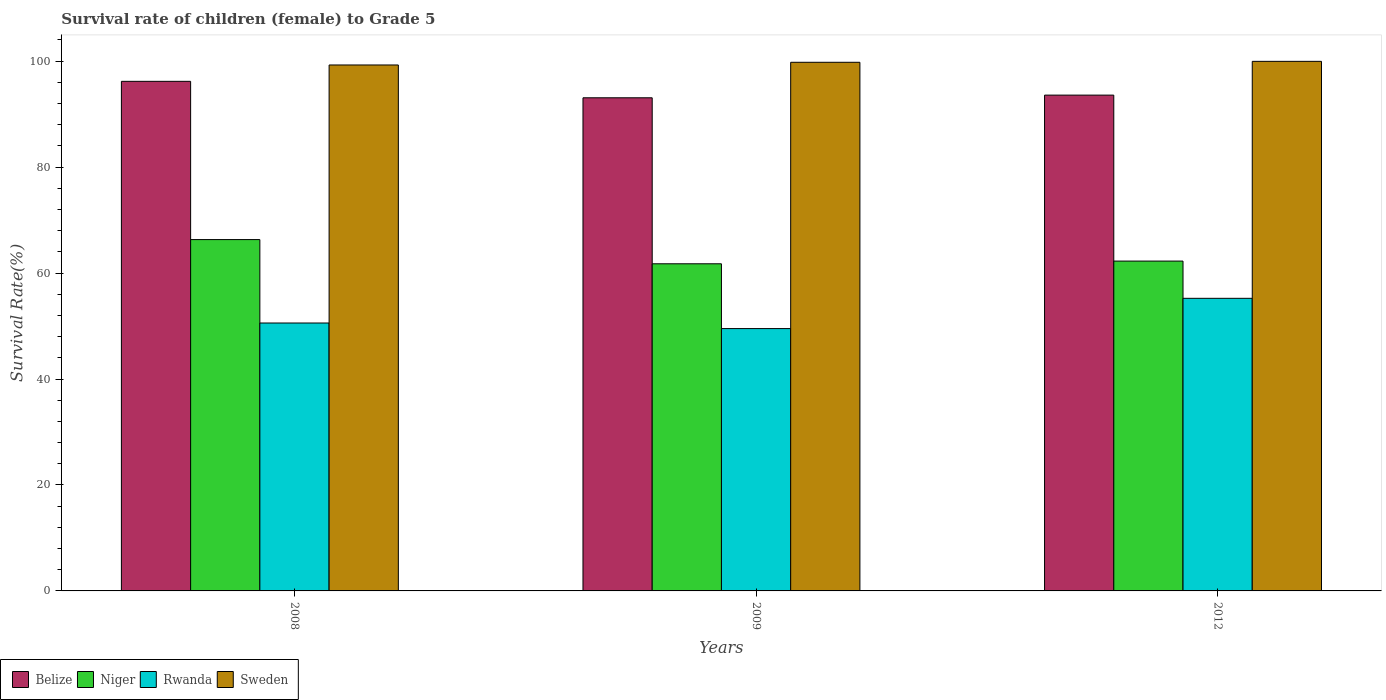How many different coloured bars are there?
Keep it short and to the point. 4. What is the label of the 1st group of bars from the left?
Offer a very short reply. 2008. In how many cases, is the number of bars for a given year not equal to the number of legend labels?
Your answer should be very brief. 0. What is the survival rate of female children to grade 5 in Niger in 2012?
Give a very brief answer. 62.26. Across all years, what is the maximum survival rate of female children to grade 5 in Sweden?
Provide a short and direct response. 99.96. Across all years, what is the minimum survival rate of female children to grade 5 in Sweden?
Make the answer very short. 99.28. In which year was the survival rate of female children to grade 5 in Niger maximum?
Keep it short and to the point. 2008. What is the total survival rate of female children to grade 5 in Rwanda in the graph?
Your answer should be compact. 155.33. What is the difference between the survival rate of female children to grade 5 in Sweden in 2009 and that in 2012?
Provide a short and direct response. -0.18. What is the difference between the survival rate of female children to grade 5 in Niger in 2008 and the survival rate of female children to grade 5 in Sweden in 2009?
Ensure brevity in your answer.  -33.47. What is the average survival rate of female children to grade 5 in Rwanda per year?
Give a very brief answer. 51.78. In the year 2012, what is the difference between the survival rate of female children to grade 5 in Niger and survival rate of female children to grade 5 in Rwanda?
Your response must be concise. 7.03. What is the ratio of the survival rate of female children to grade 5 in Rwanda in 2009 to that in 2012?
Your answer should be very brief. 0.9. What is the difference between the highest and the second highest survival rate of female children to grade 5 in Rwanda?
Provide a short and direct response. 4.66. What is the difference between the highest and the lowest survival rate of female children to grade 5 in Niger?
Keep it short and to the point. 4.57. In how many years, is the survival rate of female children to grade 5 in Belize greater than the average survival rate of female children to grade 5 in Belize taken over all years?
Offer a terse response. 1. What does the 3rd bar from the right in 2009 represents?
Provide a short and direct response. Niger. How many bars are there?
Give a very brief answer. 12. Are all the bars in the graph horizontal?
Make the answer very short. No. What is the difference between two consecutive major ticks on the Y-axis?
Your answer should be very brief. 20. Are the values on the major ticks of Y-axis written in scientific E-notation?
Provide a short and direct response. No. Does the graph contain grids?
Keep it short and to the point. No. Where does the legend appear in the graph?
Offer a terse response. Bottom left. How are the legend labels stacked?
Give a very brief answer. Horizontal. What is the title of the graph?
Give a very brief answer. Survival rate of children (female) to Grade 5. Does "Grenada" appear as one of the legend labels in the graph?
Keep it short and to the point. No. What is the label or title of the Y-axis?
Give a very brief answer. Survival Rate(%). What is the Survival Rate(%) of Belize in 2008?
Provide a short and direct response. 96.19. What is the Survival Rate(%) of Niger in 2008?
Give a very brief answer. 66.32. What is the Survival Rate(%) in Rwanda in 2008?
Your answer should be compact. 50.57. What is the Survival Rate(%) in Sweden in 2008?
Provide a short and direct response. 99.28. What is the Survival Rate(%) of Belize in 2009?
Offer a very short reply. 93.09. What is the Survival Rate(%) in Niger in 2009?
Make the answer very short. 61.75. What is the Survival Rate(%) in Rwanda in 2009?
Offer a very short reply. 49.52. What is the Survival Rate(%) of Sweden in 2009?
Your answer should be very brief. 99.79. What is the Survival Rate(%) of Belize in 2012?
Provide a short and direct response. 93.59. What is the Survival Rate(%) of Niger in 2012?
Your response must be concise. 62.26. What is the Survival Rate(%) in Rwanda in 2012?
Your answer should be compact. 55.23. What is the Survival Rate(%) in Sweden in 2012?
Offer a terse response. 99.96. Across all years, what is the maximum Survival Rate(%) of Belize?
Keep it short and to the point. 96.19. Across all years, what is the maximum Survival Rate(%) of Niger?
Make the answer very short. 66.32. Across all years, what is the maximum Survival Rate(%) of Rwanda?
Ensure brevity in your answer.  55.23. Across all years, what is the maximum Survival Rate(%) of Sweden?
Give a very brief answer. 99.96. Across all years, what is the minimum Survival Rate(%) of Belize?
Make the answer very short. 93.09. Across all years, what is the minimum Survival Rate(%) of Niger?
Offer a very short reply. 61.75. Across all years, what is the minimum Survival Rate(%) of Rwanda?
Keep it short and to the point. 49.52. Across all years, what is the minimum Survival Rate(%) in Sweden?
Keep it short and to the point. 99.28. What is the total Survival Rate(%) of Belize in the graph?
Provide a succinct answer. 282.87. What is the total Survival Rate(%) in Niger in the graph?
Provide a succinct answer. 190.33. What is the total Survival Rate(%) in Rwanda in the graph?
Offer a very short reply. 155.33. What is the total Survival Rate(%) in Sweden in the graph?
Give a very brief answer. 299.03. What is the difference between the Survival Rate(%) of Belize in 2008 and that in 2009?
Provide a short and direct response. 3.11. What is the difference between the Survival Rate(%) in Niger in 2008 and that in 2009?
Your response must be concise. 4.57. What is the difference between the Survival Rate(%) in Rwanda in 2008 and that in 2009?
Provide a succinct answer. 1.05. What is the difference between the Survival Rate(%) in Sweden in 2008 and that in 2009?
Offer a very short reply. -0.51. What is the difference between the Survival Rate(%) of Belize in 2008 and that in 2012?
Your response must be concise. 2.6. What is the difference between the Survival Rate(%) in Niger in 2008 and that in 2012?
Provide a short and direct response. 4.06. What is the difference between the Survival Rate(%) in Rwanda in 2008 and that in 2012?
Your response must be concise. -4.66. What is the difference between the Survival Rate(%) of Sweden in 2008 and that in 2012?
Your response must be concise. -0.68. What is the difference between the Survival Rate(%) of Belize in 2009 and that in 2012?
Your answer should be compact. -0.5. What is the difference between the Survival Rate(%) of Niger in 2009 and that in 2012?
Offer a terse response. -0.51. What is the difference between the Survival Rate(%) in Rwanda in 2009 and that in 2012?
Provide a short and direct response. -5.71. What is the difference between the Survival Rate(%) of Sweden in 2009 and that in 2012?
Give a very brief answer. -0.18. What is the difference between the Survival Rate(%) of Belize in 2008 and the Survival Rate(%) of Niger in 2009?
Ensure brevity in your answer.  34.44. What is the difference between the Survival Rate(%) of Belize in 2008 and the Survival Rate(%) of Rwanda in 2009?
Provide a short and direct response. 46.67. What is the difference between the Survival Rate(%) of Belize in 2008 and the Survival Rate(%) of Sweden in 2009?
Your answer should be very brief. -3.59. What is the difference between the Survival Rate(%) of Niger in 2008 and the Survival Rate(%) of Rwanda in 2009?
Make the answer very short. 16.8. What is the difference between the Survival Rate(%) in Niger in 2008 and the Survival Rate(%) in Sweden in 2009?
Make the answer very short. -33.47. What is the difference between the Survival Rate(%) in Rwanda in 2008 and the Survival Rate(%) in Sweden in 2009?
Make the answer very short. -49.21. What is the difference between the Survival Rate(%) of Belize in 2008 and the Survival Rate(%) of Niger in 2012?
Offer a very short reply. 33.93. What is the difference between the Survival Rate(%) of Belize in 2008 and the Survival Rate(%) of Rwanda in 2012?
Keep it short and to the point. 40.96. What is the difference between the Survival Rate(%) of Belize in 2008 and the Survival Rate(%) of Sweden in 2012?
Make the answer very short. -3.77. What is the difference between the Survival Rate(%) in Niger in 2008 and the Survival Rate(%) in Rwanda in 2012?
Offer a terse response. 11.09. What is the difference between the Survival Rate(%) of Niger in 2008 and the Survival Rate(%) of Sweden in 2012?
Give a very brief answer. -33.64. What is the difference between the Survival Rate(%) in Rwanda in 2008 and the Survival Rate(%) in Sweden in 2012?
Keep it short and to the point. -49.39. What is the difference between the Survival Rate(%) of Belize in 2009 and the Survival Rate(%) of Niger in 2012?
Keep it short and to the point. 30.83. What is the difference between the Survival Rate(%) of Belize in 2009 and the Survival Rate(%) of Rwanda in 2012?
Keep it short and to the point. 37.85. What is the difference between the Survival Rate(%) in Belize in 2009 and the Survival Rate(%) in Sweden in 2012?
Ensure brevity in your answer.  -6.88. What is the difference between the Survival Rate(%) of Niger in 2009 and the Survival Rate(%) of Rwanda in 2012?
Offer a terse response. 6.52. What is the difference between the Survival Rate(%) of Niger in 2009 and the Survival Rate(%) of Sweden in 2012?
Ensure brevity in your answer.  -38.21. What is the difference between the Survival Rate(%) of Rwanda in 2009 and the Survival Rate(%) of Sweden in 2012?
Provide a succinct answer. -50.44. What is the average Survival Rate(%) of Belize per year?
Your answer should be compact. 94.29. What is the average Survival Rate(%) of Niger per year?
Your answer should be compact. 63.44. What is the average Survival Rate(%) in Rwanda per year?
Offer a very short reply. 51.78. What is the average Survival Rate(%) of Sweden per year?
Offer a very short reply. 99.68. In the year 2008, what is the difference between the Survival Rate(%) in Belize and Survival Rate(%) in Niger?
Your answer should be very brief. 29.87. In the year 2008, what is the difference between the Survival Rate(%) of Belize and Survival Rate(%) of Rwanda?
Your answer should be very brief. 45.62. In the year 2008, what is the difference between the Survival Rate(%) in Belize and Survival Rate(%) in Sweden?
Offer a terse response. -3.09. In the year 2008, what is the difference between the Survival Rate(%) in Niger and Survival Rate(%) in Rwanda?
Make the answer very short. 15.75. In the year 2008, what is the difference between the Survival Rate(%) of Niger and Survival Rate(%) of Sweden?
Your response must be concise. -32.96. In the year 2008, what is the difference between the Survival Rate(%) in Rwanda and Survival Rate(%) in Sweden?
Keep it short and to the point. -48.71. In the year 2009, what is the difference between the Survival Rate(%) in Belize and Survival Rate(%) in Niger?
Ensure brevity in your answer.  31.34. In the year 2009, what is the difference between the Survival Rate(%) in Belize and Survival Rate(%) in Rwanda?
Offer a very short reply. 43.57. In the year 2009, what is the difference between the Survival Rate(%) in Belize and Survival Rate(%) in Sweden?
Give a very brief answer. -6.7. In the year 2009, what is the difference between the Survival Rate(%) in Niger and Survival Rate(%) in Rwanda?
Offer a very short reply. 12.23. In the year 2009, what is the difference between the Survival Rate(%) in Niger and Survival Rate(%) in Sweden?
Keep it short and to the point. -38.04. In the year 2009, what is the difference between the Survival Rate(%) of Rwanda and Survival Rate(%) of Sweden?
Offer a very short reply. -50.27. In the year 2012, what is the difference between the Survival Rate(%) in Belize and Survival Rate(%) in Niger?
Offer a very short reply. 31.33. In the year 2012, what is the difference between the Survival Rate(%) in Belize and Survival Rate(%) in Rwanda?
Give a very brief answer. 38.36. In the year 2012, what is the difference between the Survival Rate(%) of Belize and Survival Rate(%) of Sweden?
Your answer should be compact. -6.37. In the year 2012, what is the difference between the Survival Rate(%) in Niger and Survival Rate(%) in Rwanda?
Provide a succinct answer. 7.03. In the year 2012, what is the difference between the Survival Rate(%) of Niger and Survival Rate(%) of Sweden?
Provide a succinct answer. -37.7. In the year 2012, what is the difference between the Survival Rate(%) in Rwanda and Survival Rate(%) in Sweden?
Offer a very short reply. -44.73. What is the ratio of the Survival Rate(%) of Belize in 2008 to that in 2009?
Your answer should be very brief. 1.03. What is the ratio of the Survival Rate(%) of Niger in 2008 to that in 2009?
Keep it short and to the point. 1.07. What is the ratio of the Survival Rate(%) in Rwanda in 2008 to that in 2009?
Give a very brief answer. 1.02. What is the ratio of the Survival Rate(%) in Sweden in 2008 to that in 2009?
Provide a succinct answer. 0.99. What is the ratio of the Survival Rate(%) of Belize in 2008 to that in 2012?
Make the answer very short. 1.03. What is the ratio of the Survival Rate(%) of Niger in 2008 to that in 2012?
Your answer should be compact. 1.07. What is the ratio of the Survival Rate(%) of Rwanda in 2008 to that in 2012?
Give a very brief answer. 0.92. What is the ratio of the Survival Rate(%) in Sweden in 2008 to that in 2012?
Your answer should be compact. 0.99. What is the ratio of the Survival Rate(%) in Niger in 2009 to that in 2012?
Make the answer very short. 0.99. What is the ratio of the Survival Rate(%) in Rwanda in 2009 to that in 2012?
Make the answer very short. 0.9. What is the ratio of the Survival Rate(%) of Sweden in 2009 to that in 2012?
Give a very brief answer. 1. What is the difference between the highest and the second highest Survival Rate(%) in Belize?
Provide a short and direct response. 2.6. What is the difference between the highest and the second highest Survival Rate(%) of Niger?
Make the answer very short. 4.06. What is the difference between the highest and the second highest Survival Rate(%) of Rwanda?
Make the answer very short. 4.66. What is the difference between the highest and the second highest Survival Rate(%) of Sweden?
Offer a terse response. 0.18. What is the difference between the highest and the lowest Survival Rate(%) of Belize?
Give a very brief answer. 3.11. What is the difference between the highest and the lowest Survival Rate(%) in Niger?
Give a very brief answer. 4.57. What is the difference between the highest and the lowest Survival Rate(%) of Rwanda?
Offer a very short reply. 5.71. What is the difference between the highest and the lowest Survival Rate(%) in Sweden?
Give a very brief answer. 0.68. 